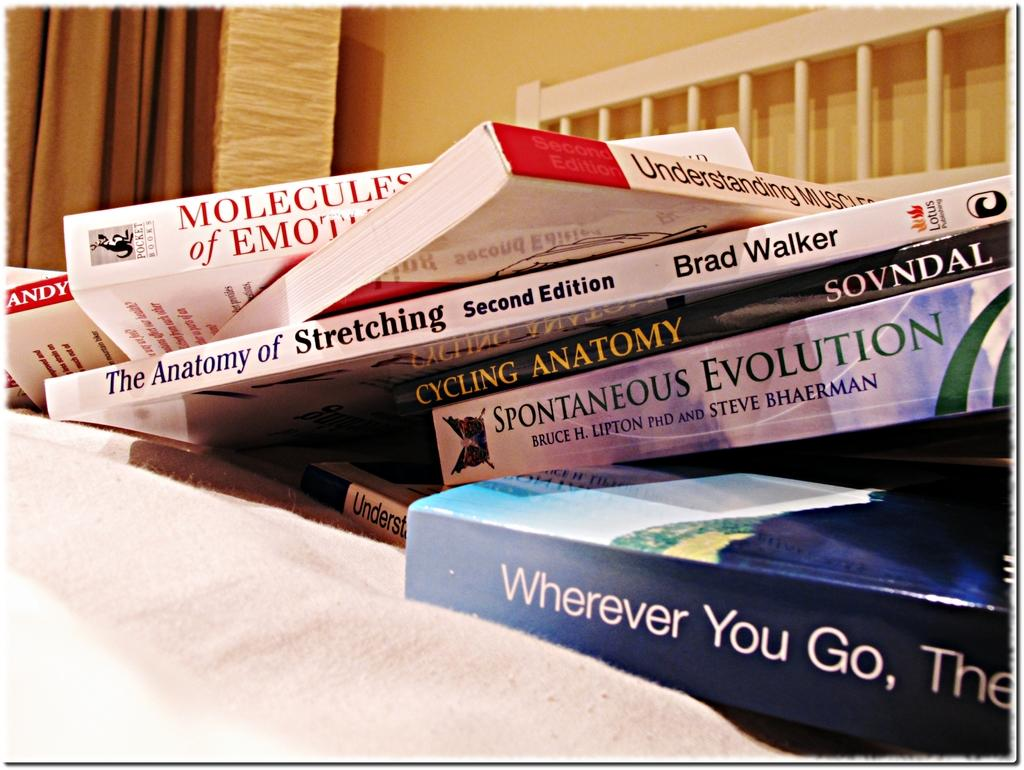What objects are arranged on the white colored cloth in the image? There are books arranged on a white colored cloth in the image. What can be seen in the background of the image? There is a curtain, a fence, and a yellow color wall in the background of the image. How many mice are sitting on the books in the image? There are no mice present in the image; it only shows books arranged on a white cloth. Can you see any icicles hanging from the yellow wall in the image? There are no icicles visible in the image; it only shows a yellow wall in the background. 